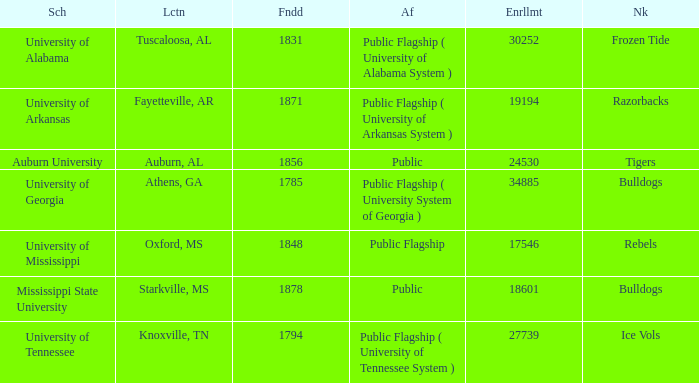What is the nickname of the University of Alabama? Frozen Tide. 